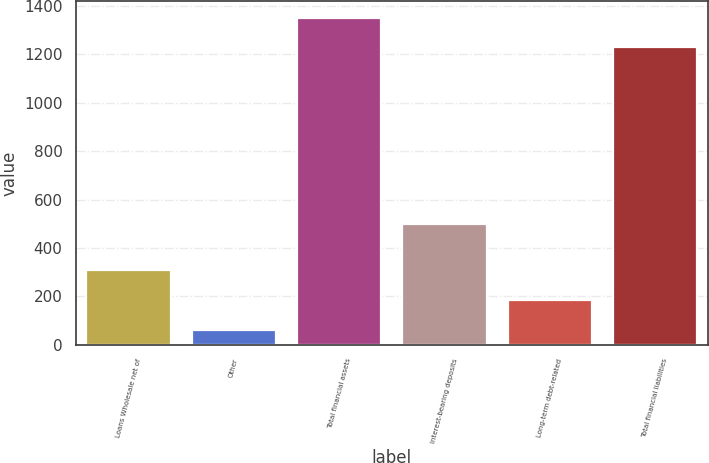<chart> <loc_0><loc_0><loc_500><loc_500><bar_chart><fcel>Loans Wholesale net of<fcel>Other<fcel>Total financial assets<fcel>Interest-bearing deposits<fcel>Long-term debt-related<fcel>Total financial liabilities<nl><fcel>306.7<fcel>61.8<fcel>1352.65<fcel>498.3<fcel>184.25<fcel>1230.2<nl></chart> 